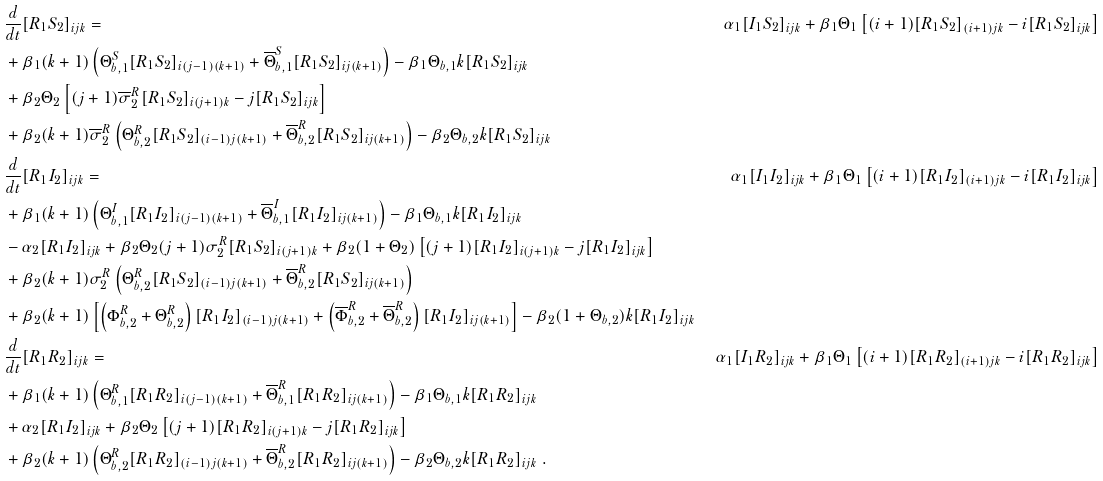Convert formula to latex. <formula><loc_0><loc_0><loc_500><loc_500>& \frac { d } { d t } [ R _ { 1 } S _ { 2 } ] _ { i j k } = & \ \alpha _ { 1 } [ I _ { 1 } S _ { 2 } ] _ { i j k } + \beta _ { 1 } \Theta _ { 1 } \left [ ( i + 1 ) [ R _ { 1 } S _ { 2 } ] _ { ( i + 1 ) j k } - i [ R _ { 1 } S _ { 2 } ] _ { i j k } \right ] \\ & + \beta _ { 1 } ( k + 1 ) \left ( \Theta _ { b , 1 } ^ { S } [ R _ { 1 } S _ { 2 } ] _ { i ( j - 1 ) ( k + 1 ) } + \overline { \Theta } _ { b , 1 } ^ { S } [ R _ { 1 } S _ { 2 } ] _ { i j ( k + 1 ) } \right ) - \beta _ { 1 } \Theta _ { b , 1 } k [ R _ { 1 } S _ { 2 } ] _ { i j k } \\ & + \beta _ { 2 } \Theta _ { 2 } \left [ ( j + 1 ) \overline { \sigma } _ { 2 } ^ { R } [ R _ { 1 } S _ { 2 } ] _ { i ( j + 1 ) k } - j [ R _ { 1 } S _ { 2 } ] _ { i j k } \right ] \\ & + \beta _ { 2 } ( k + 1 ) \overline { \sigma } _ { 2 } ^ { R } \left ( \Theta _ { b , 2 } ^ { R } [ R _ { 1 } S _ { 2 } ] _ { ( i - 1 ) j ( k + 1 ) } + \overline { \Theta } _ { b , 2 } ^ { R } [ R _ { 1 } S _ { 2 } ] _ { i j ( k + 1 ) } \right ) - \beta _ { 2 } \Theta _ { b , 2 } k [ R _ { 1 } S _ { 2 } ] _ { i j k } \\ & \frac { d } { d t } [ R _ { 1 } I _ { 2 } ] _ { i j k } = & \ \alpha _ { 1 } [ I _ { 1 } I _ { 2 } ] _ { i j k } + \beta _ { 1 } \Theta _ { 1 } \left [ ( i + 1 ) [ R _ { 1 } I _ { 2 } ] _ { ( i + 1 ) j k } - i [ R _ { 1 } I _ { 2 } ] _ { i j k } \right ] \\ & + \beta _ { 1 } ( k + 1 ) \left ( \Theta _ { b , 1 } ^ { I } [ R _ { 1 } I _ { 2 } ] _ { i ( j - 1 ) ( k + 1 ) } + \overline { \Theta } _ { b , 1 } ^ { I } [ R _ { 1 } I _ { 2 } ] _ { i j ( k + 1 ) } \right ) - \beta _ { 1 } \Theta _ { b , 1 } k [ R _ { 1 } I _ { 2 } ] _ { i j k } \\ & - \alpha _ { 2 } [ R _ { 1 } I _ { 2 } ] _ { i j k } + \beta _ { 2 } \Theta _ { 2 } ( j + 1 ) \sigma _ { 2 } ^ { R } [ R _ { 1 } S _ { 2 } ] _ { i ( j + 1 ) k } + \beta _ { 2 } ( 1 + \Theta _ { 2 } ) \left [ ( j + 1 ) [ R _ { 1 } I _ { 2 } ] _ { i ( j + 1 ) k } - j [ R _ { 1 } I _ { 2 } ] _ { i j k } \right ] \\ & + \beta _ { 2 } ( k + 1 ) \sigma _ { 2 } ^ { R } \left ( \Theta _ { b , 2 } ^ { R } [ R _ { 1 } S _ { 2 } ] _ { ( i - 1 ) j ( k + 1 ) } + \overline { \Theta } _ { b , 2 } ^ { R } [ R _ { 1 } S _ { 2 } ] _ { i j ( k + 1 ) } \right ) \\ & + \beta _ { 2 } ( k + 1 ) \left [ \left ( \Phi _ { b , 2 } ^ { R } + \Theta _ { b , 2 } ^ { R } \right ) [ R _ { 1 } I _ { 2 } ] _ { ( i - 1 ) j ( k + 1 ) } + \left ( \overline { \Phi } _ { b , 2 } ^ { R } + \overline { \Theta } _ { b , 2 } ^ { R } \right ) [ R _ { 1 } I _ { 2 } ] _ { i j ( k + 1 ) } \right ] - \beta _ { 2 } ( 1 + \Theta _ { b , 2 } ) k [ R _ { 1 } I _ { 2 } ] _ { i j k } \\ & \frac { d } { d t } [ R _ { 1 } R _ { 2 } ] _ { i j k } = & \ \alpha _ { 1 } [ I _ { 1 } R _ { 2 } ] _ { i j k } + \beta _ { 1 } \Theta _ { 1 } \left [ ( i + 1 ) [ R _ { 1 } R _ { 2 } ] _ { ( i + 1 ) j k } - i [ R _ { 1 } R _ { 2 } ] _ { i j k } \right ] \\ & + \beta _ { 1 } ( k + 1 ) \left ( \Theta _ { b , 1 } ^ { R } [ R _ { 1 } R _ { 2 } ] _ { i ( j - 1 ) ( k + 1 ) } + \overline { \Theta } _ { b , 1 } ^ { R } [ R _ { 1 } R _ { 2 } ] _ { i j ( k + 1 ) } \right ) - \beta _ { 1 } \Theta _ { b , 1 } k [ R _ { 1 } R _ { 2 } ] _ { i j k } \\ & + \alpha _ { 2 } [ R _ { 1 } I _ { 2 } ] _ { i j k } + \beta _ { 2 } \Theta _ { 2 } \left [ ( j + 1 ) [ R _ { 1 } R _ { 2 } ] _ { i ( j + 1 ) k } - j [ R _ { 1 } R _ { 2 } ] _ { i j k } \right ] \\ & + \beta _ { 2 } ( k + 1 ) \left ( \Theta _ { b , 2 } ^ { R } [ R _ { 1 } R _ { 2 } ] _ { ( i - 1 ) j ( k + 1 ) } + \overline { \Theta } _ { b , 2 } ^ { R } [ R _ { 1 } R _ { 2 } ] _ { i j ( k + 1 ) } \right ) - \beta _ { 2 } \Theta _ { b , 2 } k [ R _ { 1 } R _ { 2 } ] _ { i j k } \ .</formula> 